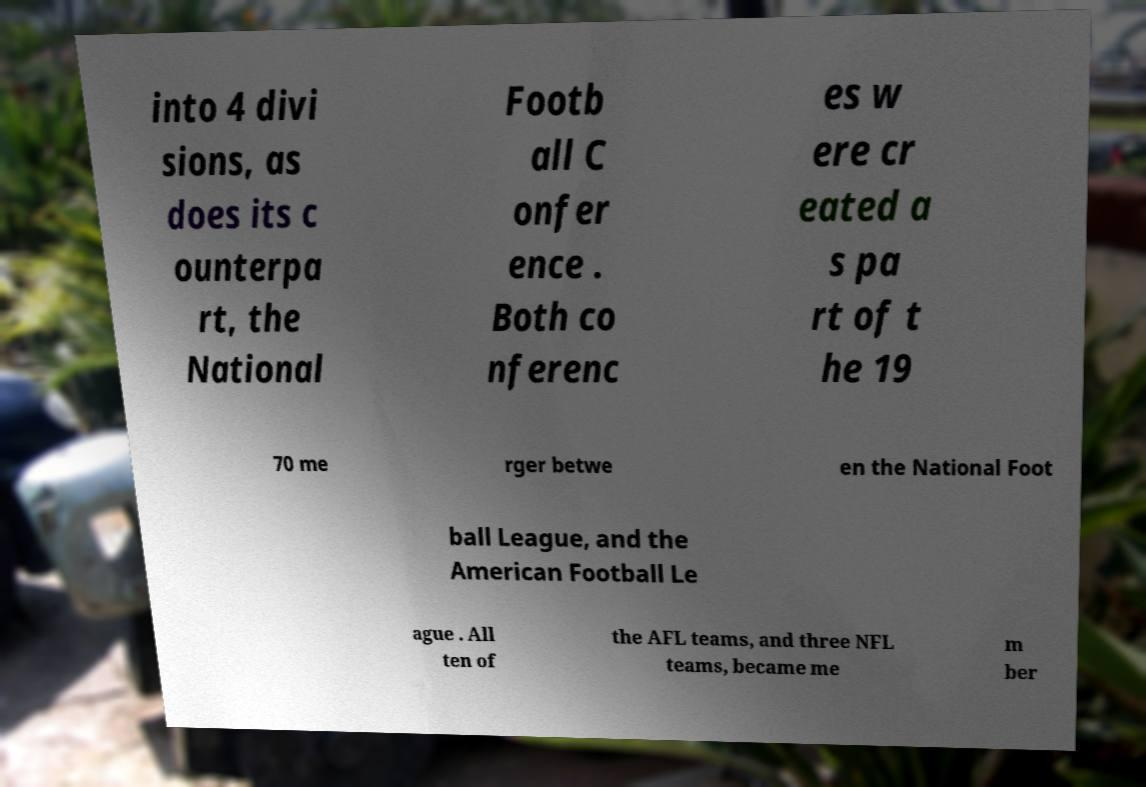Can you accurately transcribe the text from the provided image for me? into 4 divi sions, as does its c ounterpa rt, the National Footb all C onfer ence . Both co nferenc es w ere cr eated a s pa rt of t he 19 70 me rger betwe en the National Foot ball League, and the American Football Le ague . All ten of the AFL teams, and three NFL teams, became me m ber 